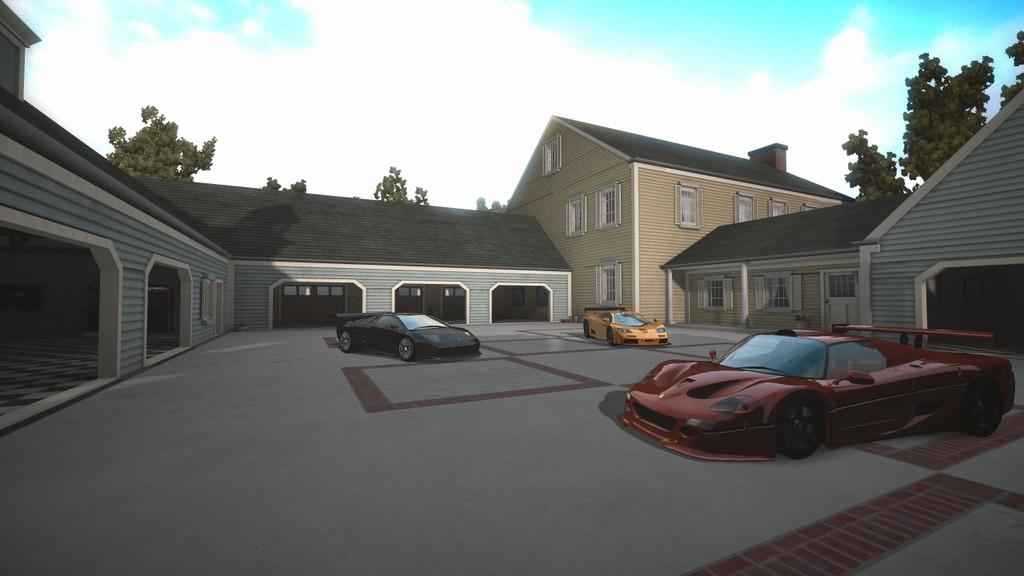What type of structures are animated in the image? There are animated buildings in the image. What type of small shelter is present in the image? There is a shed in the image. What type of vehicles can be seen in the image? There are cars in the image. What architectural feature is present in the buildings and the shed? There are windows in the image. What type of natural vegetation is present in the image? There are trees in the image. What part of the natural environment is visible in the image? The sky is visible in the image. Can you tell me how many basketballs are visible in the image? There are no basketballs present in the image. What type of train can be seen passing by the animated buildings in the image? There is no train present in the image; it only features animated buildings, a shed, cars, windows, trees, and the sky. 